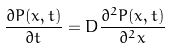<formula> <loc_0><loc_0><loc_500><loc_500>\frac { \partial P ( x , t ) } { \partial t } = D \frac { \partial ^ { 2 } P ( x , t ) } { \partial ^ { 2 } x }</formula> 